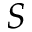Convert formula to latex. <formula><loc_0><loc_0><loc_500><loc_500>S</formula> 